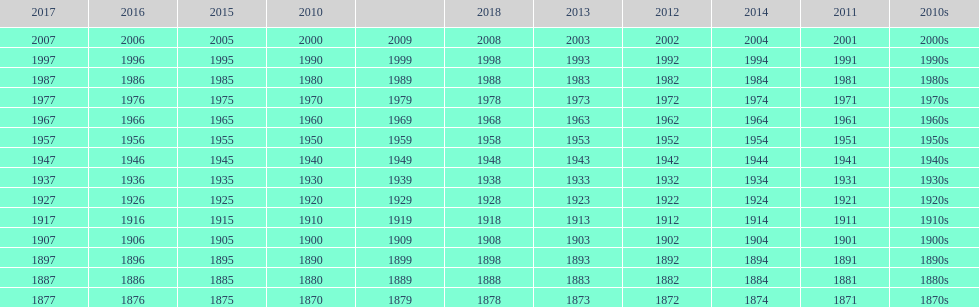What is the earliest year that a film was released? 1870. 